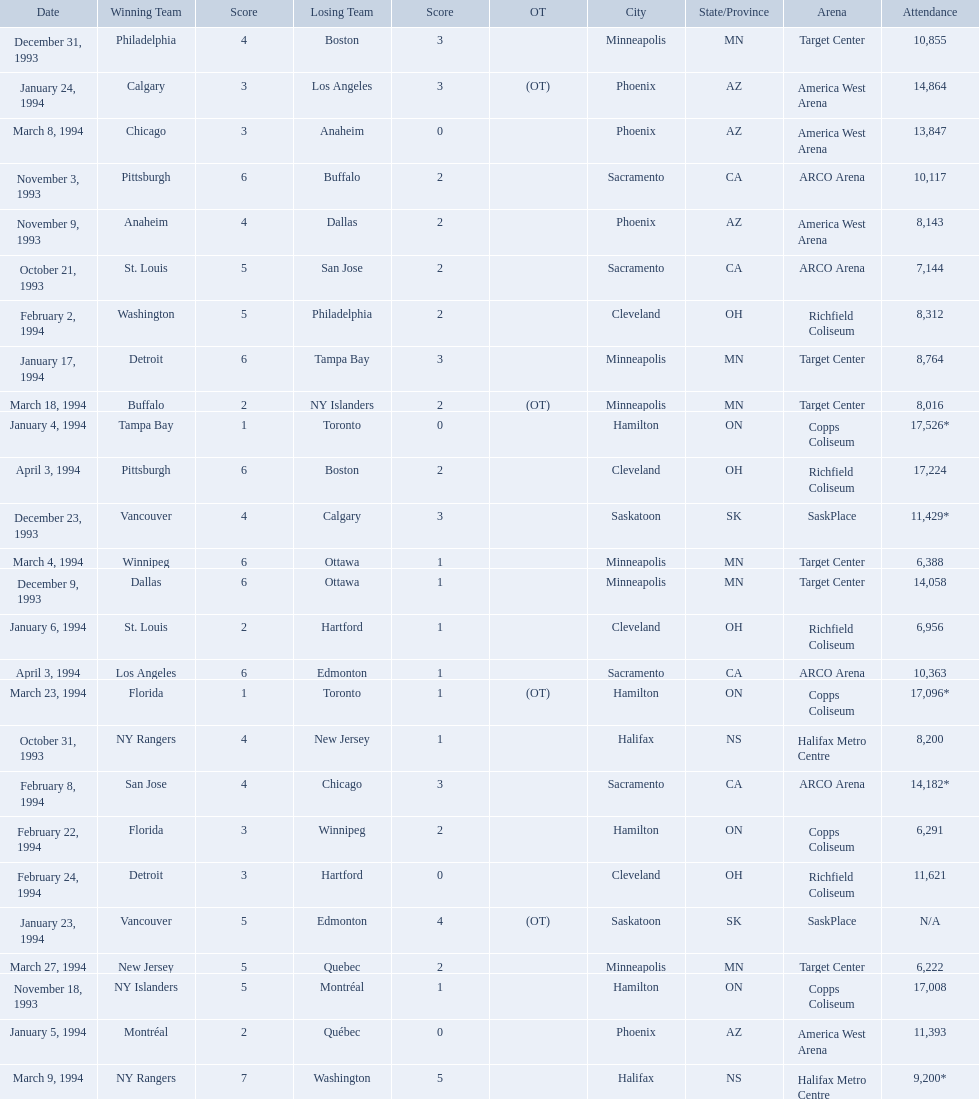Which was the highest attendance for a game? 17,526*. What was the date of the game with an attendance of 17,526? January 4, 1994. 